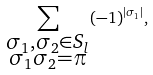Convert formula to latex. <formula><loc_0><loc_0><loc_500><loc_500>\sum _ { \substack { \sigma _ { 1 } , \sigma _ { 2 } \in S _ { l } \\ \sigma _ { 1 } \sigma _ { 2 } = \pi } } ( - 1 ) ^ { | \sigma _ { 1 } | } ,</formula> 